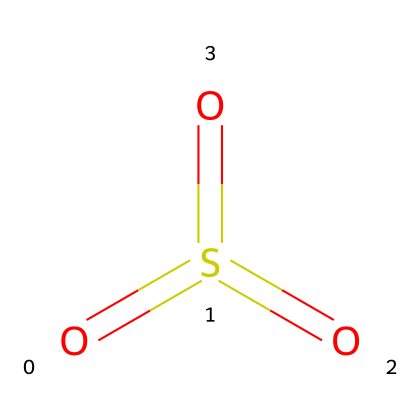What is the molecular formula of sulfur trioxide? The SMILES representation depicts sulfur (S) bonded to three oxygen (O) atoms, hence the molecular formula is derived by counting each atom.
Answer: SO3 How many resonance structures can sulfur trioxide have? Sulfur trioxide can exhibit resonance due to the delocalization of electrons across the three oxygen atoms, allowing for multiple structures. Specifically, it has three resonance structures.
Answer: 3 What type of hybridization is present in the sulfur atom of sulfur trioxide? The sulfur atom is bonded to three oxygen atoms and has a formal positive charge on sulfur. This requires an sp2 hybridization to accommodate the geometry and bonding arrangement.
Answer: sp2 What is the total number of bonds in sulfur trioxide? In the structure represented, there are three double bonds between sulfur and each of the three oxygen atoms, resulting in a total bond count of three.
Answer: 3 Why is sulfur trioxide considered a hypervalent compound? Hypervalent compounds are those that have more than an octet of electrons around the central atom; sulfur trioxide fits this definition as sulfur is surrounded by six electrons from the three double bonds.
Answer: More than an octet What is the geometry of sulfur trioxide? The arrangement of the oxygen atoms around sulfur with sp2 hybridization leads to a trigonal planar molecular geometry, which is characteristic of this structure.
Answer: Trigonal planar 